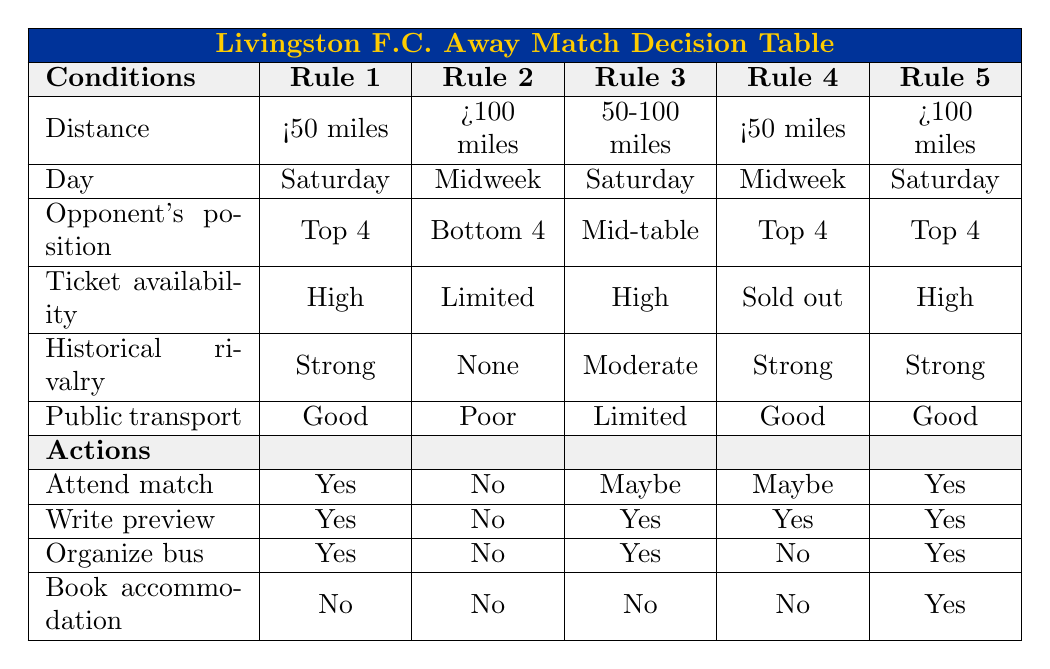What is the action for attending a match against a bottom 4 team on a midweek? According to Rule 2, if the opponent is in the bottom 4 and the match is on a midweek, the action for attending the match is "No".
Answer: No How many rules indicate that it is possible to book accommodation? Analyzing the table, booking accommodation is indicated as "Yes" only in Rule 5, which pertains to a match that is more than 100 miles away on a Saturday against a top 4 team with high ticket availability and strong rivalry. Therefore, there is 1 rule that allows booking accommodation.
Answer: 1 Is there any match that offers high ticket availability and how many of those rules allow for organizing a supporter bus? Referring to the table, Rules 1, 3, and 5 have high ticket availability, and among these rules, Rules 1, 3, and 5 also allow for organizing a supporter bus. Thus, the count of rules allowing for a supporter bus with high ticket availability is 3.
Answer: 3 For a Saturday match against a top 4 team within 50 miles, what actions are allowed? Examining Rule 1, the actions available for a Saturday match against a top 4 team within 50 miles are "Yes" for attending the match, "Yes" for writing a match preview, "Yes" for organizing a bus, and "No" for booking accommodation.
Answer: Attend match: Yes, Write preview: Yes, Organize bus: Yes, Book accommodation: No If a match is less than 50 miles away on a Saturday and the tickets are sold out, will references be made in the fanzine? Looking at Rule 4, for a match under these conditions—less than 50 miles away on a Saturday with sold out tickets—the option to write a preview is "Yes". Therefore, it confirms that references will be made in the fanzine.
Answer: Yes 